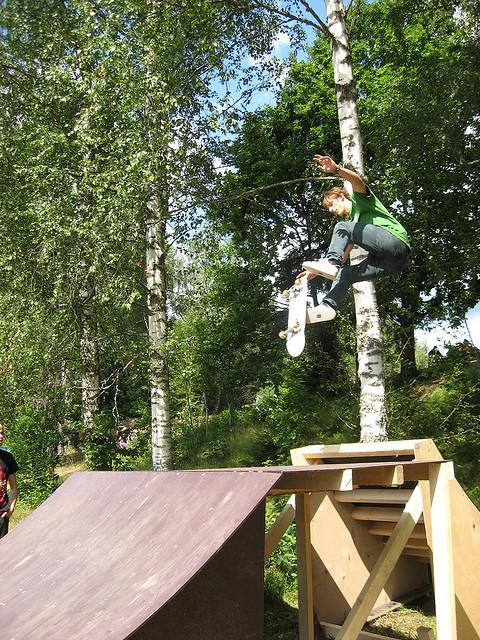What is this large contraption called?

Choices:
A) skateboarding ramp
B) shed
C) roof
D) slope skateboarding ramp 